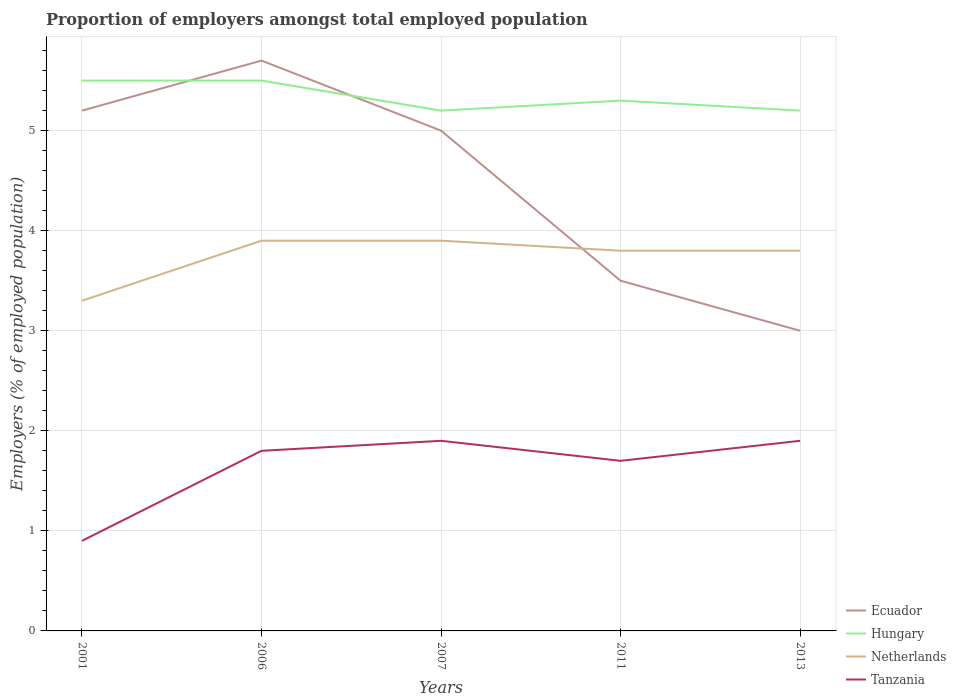Is the number of lines equal to the number of legend labels?
Your answer should be very brief. Yes. Across all years, what is the maximum proportion of employers in Netherlands?
Provide a short and direct response. 3.3. In which year was the proportion of employers in Hungary maximum?
Your response must be concise. 2007. What is the difference between the highest and the second highest proportion of employers in Hungary?
Offer a terse response. 0.3. How many lines are there?
Provide a succinct answer. 4. How many years are there in the graph?
Give a very brief answer. 5. Does the graph contain any zero values?
Give a very brief answer. No. Does the graph contain grids?
Your answer should be compact. Yes. Where does the legend appear in the graph?
Your answer should be very brief. Bottom right. How are the legend labels stacked?
Offer a very short reply. Vertical. What is the title of the graph?
Your answer should be very brief. Proportion of employers amongst total employed population. What is the label or title of the X-axis?
Keep it short and to the point. Years. What is the label or title of the Y-axis?
Provide a succinct answer. Employers (% of employed population). What is the Employers (% of employed population) of Ecuador in 2001?
Make the answer very short. 5.2. What is the Employers (% of employed population) in Hungary in 2001?
Your response must be concise. 5.5. What is the Employers (% of employed population) of Netherlands in 2001?
Your answer should be very brief. 3.3. What is the Employers (% of employed population) of Tanzania in 2001?
Offer a terse response. 0.9. What is the Employers (% of employed population) of Ecuador in 2006?
Give a very brief answer. 5.7. What is the Employers (% of employed population) in Netherlands in 2006?
Your answer should be very brief. 3.9. What is the Employers (% of employed population) of Tanzania in 2006?
Ensure brevity in your answer.  1.8. What is the Employers (% of employed population) in Hungary in 2007?
Make the answer very short. 5.2. What is the Employers (% of employed population) in Netherlands in 2007?
Provide a succinct answer. 3.9. What is the Employers (% of employed population) of Tanzania in 2007?
Ensure brevity in your answer.  1.9. What is the Employers (% of employed population) in Hungary in 2011?
Keep it short and to the point. 5.3. What is the Employers (% of employed population) of Netherlands in 2011?
Your answer should be compact. 3.8. What is the Employers (% of employed population) of Tanzania in 2011?
Give a very brief answer. 1.7. What is the Employers (% of employed population) of Ecuador in 2013?
Your answer should be very brief. 3. What is the Employers (% of employed population) in Hungary in 2013?
Provide a succinct answer. 5.2. What is the Employers (% of employed population) in Netherlands in 2013?
Your response must be concise. 3.8. What is the Employers (% of employed population) in Tanzania in 2013?
Your response must be concise. 1.9. Across all years, what is the maximum Employers (% of employed population) in Ecuador?
Offer a terse response. 5.7. Across all years, what is the maximum Employers (% of employed population) of Netherlands?
Provide a succinct answer. 3.9. Across all years, what is the maximum Employers (% of employed population) of Tanzania?
Your answer should be compact. 1.9. Across all years, what is the minimum Employers (% of employed population) of Hungary?
Your answer should be very brief. 5.2. Across all years, what is the minimum Employers (% of employed population) of Netherlands?
Give a very brief answer. 3.3. Across all years, what is the minimum Employers (% of employed population) of Tanzania?
Make the answer very short. 0.9. What is the total Employers (% of employed population) of Ecuador in the graph?
Your answer should be very brief. 22.4. What is the total Employers (% of employed population) in Hungary in the graph?
Offer a very short reply. 26.7. What is the total Employers (% of employed population) of Netherlands in the graph?
Give a very brief answer. 18.7. What is the total Employers (% of employed population) of Tanzania in the graph?
Provide a succinct answer. 8.2. What is the difference between the Employers (% of employed population) of Ecuador in 2001 and that in 2006?
Provide a succinct answer. -0.5. What is the difference between the Employers (% of employed population) of Ecuador in 2001 and that in 2011?
Provide a succinct answer. 1.7. What is the difference between the Employers (% of employed population) of Netherlands in 2001 and that in 2011?
Your answer should be compact. -0.5. What is the difference between the Employers (% of employed population) of Tanzania in 2001 and that in 2011?
Your response must be concise. -0.8. What is the difference between the Employers (% of employed population) in Hungary in 2001 and that in 2013?
Offer a terse response. 0.3. What is the difference between the Employers (% of employed population) of Tanzania in 2001 and that in 2013?
Make the answer very short. -1. What is the difference between the Employers (% of employed population) of Ecuador in 2006 and that in 2007?
Your answer should be compact. 0.7. What is the difference between the Employers (% of employed population) of Tanzania in 2006 and that in 2007?
Provide a succinct answer. -0.1. What is the difference between the Employers (% of employed population) of Ecuador in 2006 and that in 2011?
Provide a succinct answer. 2.2. What is the difference between the Employers (% of employed population) of Netherlands in 2006 and that in 2011?
Ensure brevity in your answer.  0.1. What is the difference between the Employers (% of employed population) of Tanzania in 2006 and that in 2011?
Offer a very short reply. 0.1. What is the difference between the Employers (% of employed population) in Netherlands in 2006 and that in 2013?
Provide a short and direct response. 0.1. What is the difference between the Employers (% of employed population) of Tanzania in 2007 and that in 2011?
Provide a short and direct response. 0.2. What is the difference between the Employers (% of employed population) in Ecuador in 2007 and that in 2013?
Offer a terse response. 2. What is the difference between the Employers (% of employed population) of Netherlands in 2007 and that in 2013?
Make the answer very short. 0.1. What is the difference between the Employers (% of employed population) of Tanzania in 2007 and that in 2013?
Offer a terse response. 0. What is the difference between the Employers (% of employed population) in Hungary in 2011 and that in 2013?
Keep it short and to the point. 0.1. What is the difference between the Employers (% of employed population) of Ecuador in 2001 and the Employers (% of employed population) of Netherlands in 2006?
Provide a succinct answer. 1.3. What is the difference between the Employers (% of employed population) in Ecuador in 2001 and the Employers (% of employed population) in Tanzania in 2006?
Ensure brevity in your answer.  3.4. What is the difference between the Employers (% of employed population) of Ecuador in 2001 and the Employers (% of employed population) of Netherlands in 2007?
Ensure brevity in your answer.  1.3. What is the difference between the Employers (% of employed population) of Hungary in 2001 and the Employers (% of employed population) of Tanzania in 2007?
Ensure brevity in your answer.  3.6. What is the difference between the Employers (% of employed population) of Netherlands in 2001 and the Employers (% of employed population) of Tanzania in 2007?
Offer a very short reply. 1.4. What is the difference between the Employers (% of employed population) of Ecuador in 2001 and the Employers (% of employed population) of Hungary in 2011?
Provide a short and direct response. -0.1. What is the difference between the Employers (% of employed population) in Hungary in 2001 and the Employers (% of employed population) in Netherlands in 2011?
Keep it short and to the point. 1.7. What is the difference between the Employers (% of employed population) of Ecuador in 2001 and the Employers (% of employed population) of Tanzania in 2013?
Offer a very short reply. 3.3. What is the difference between the Employers (% of employed population) in Hungary in 2001 and the Employers (% of employed population) in Tanzania in 2013?
Ensure brevity in your answer.  3.6. What is the difference between the Employers (% of employed population) in Netherlands in 2001 and the Employers (% of employed population) in Tanzania in 2013?
Your answer should be compact. 1.4. What is the difference between the Employers (% of employed population) of Ecuador in 2006 and the Employers (% of employed population) of Tanzania in 2007?
Offer a very short reply. 3.8. What is the difference between the Employers (% of employed population) in Netherlands in 2006 and the Employers (% of employed population) in Tanzania in 2007?
Give a very brief answer. 2. What is the difference between the Employers (% of employed population) of Ecuador in 2006 and the Employers (% of employed population) of Hungary in 2011?
Make the answer very short. 0.4. What is the difference between the Employers (% of employed population) in Ecuador in 2006 and the Employers (% of employed population) in Netherlands in 2011?
Offer a terse response. 1.9. What is the difference between the Employers (% of employed population) of Hungary in 2006 and the Employers (% of employed population) of Netherlands in 2011?
Your response must be concise. 1.7. What is the difference between the Employers (% of employed population) in Netherlands in 2006 and the Employers (% of employed population) in Tanzania in 2011?
Make the answer very short. 2.2. What is the difference between the Employers (% of employed population) of Ecuador in 2006 and the Employers (% of employed population) of Netherlands in 2013?
Your answer should be compact. 1.9. What is the difference between the Employers (% of employed population) in Ecuador in 2006 and the Employers (% of employed population) in Tanzania in 2013?
Your response must be concise. 3.8. What is the difference between the Employers (% of employed population) of Hungary in 2006 and the Employers (% of employed population) of Netherlands in 2013?
Offer a very short reply. 1.7. What is the difference between the Employers (% of employed population) in Netherlands in 2006 and the Employers (% of employed population) in Tanzania in 2013?
Keep it short and to the point. 2. What is the difference between the Employers (% of employed population) of Ecuador in 2007 and the Employers (% of employed population) of Hungary in 2011?
Provide a succinct answer. -0.3. What is the difference between the Employers (% of employed population) in Ecuador in 2007 and the Employers (% of employed population) in Netherlands in 2011?
Your response must be concise. 1.2. What is the difference between the Employers (% of employed population) of Hungary in 2007 and the Employers (% of employed population) of Netherlands in 2011?
Offer a very short reply. 1.4. What is the difference between the Employers (% of employed population) of Hungary in 2007 and the Employers (% of employed population) of Tanzania in 2011?
Give a very brief answer. 3.5. What is the difference between the Employers (% of employed population) of Netherlands in 2007 and the Employers (% of employed population) of Tanzania in 2011?
Your response must be concise. 2.2. What is the difference between the Employers (% of employed population) in Ecuador in 2007 and the Employers (% of employed population) in Netherlands in 2013?
Provide a succinct answer. 1.2. What is the difference between the Employers (% of employed population) in Ecuador in 2007 and the Employers (% of employed population) in Tanzania in 2013?
Your response must be concise. 3.1. What is the difference between the Employers (% of employed population) in Hungary in 2007 and the Employers (% of employed population) in Netherlands in 2013?
Your answer should be compact. 1.4. What is the difference between the Employers (% of employed population) in Hungary in 2007 and the Employers (% of employed population) in Tanzania in 2013?
Keep it short and to the point. 3.3. What is the average Employers (% of employed population) of Ecuador per year?
Your answer should be compact. 4.48. What is the average Employers (% of employed population) of Hungary per year?
Provide a succinct answer. 5.34. What is the average Employers (% of employed population) of Netherlands per year?
Make the answer very short. 3.74. What is the average Employers (% of employed population) in Tanzania per year?
Offer a terse response. 1.64. In the year 2001, what is the difference between the Employers (% of employed population) in Ecuador and Employers (% of employed population) in Hungary?
Your response must be concise. -0.3. In the year 2001, what is the difference between the Employers (% of employed population) of Hungary and Employers (% of employed population) of Tanzania?
Provide a succinct answer. 4.6. In the year 2001, what is the difference between the Employers (% of employed population) in Netherlands and Employers (% of employed population) in Tanzania?
Offer a very short reply. 2.4. In the year 2006, what is the difference between the Employers (% of employed population) in Ecuador and Employers (% of employed population) in Netherlands?
Ensure brevity in your answer.  1.8. In the year 2006, what is the difference between the Employers (% of employed population) of Ecuador and Employers (% of employed population) of Tanzania?
Provide a short and direct response. 3.9. In the year 2006, what is the difference between the Employers (% of employed population) of Hungary and Employers (% of employed population) of Netherlands?
Your response must be concise. 1.6. In the year 2006, what is the difference between the Employers (% of employed population) of Hungary and Employers (% of employed population) of Tanzania?
Make the answer very short. 3.7. In the year 2006, what is the difference between the Employers (% of employed population) of Netherlands and Employers (% of employed population) of Tanzania?
Provide a succinct answer. 2.1. In the year 2007, what is the difference between the Employers (% of employed population) of Ecuador and Employers (% of employed population) of Hungary?
Provide a short and direct response. -0.2. In the year 2011, what is the difference between the Employers (% of employed population) of Ecuador and Employers (% of employed population) of Netherlands?
Offer a very short reply. -0.3. In the year 2011, what is the difference between the Employers (% of employed population) in Ecuador and Employers (% of employed population) in Tanzania?
Ensure brevity in your answer.  1.8. In the year 2013, what is the difference between the Employers (% of employed population) of Ecuador and Employers (% of employed population) of Hungary?
Make the answer very short. -2.2. In the year 2013, what is the difference between the Employers (% of employed population) of Ecuador and Employers (% of employed population) of Tanzania?
Your answer should be very brief. 1.1. In the year 2013, what is the difference between the Employers (% of employed population) in Hungary and Employers (% of employed population) in Netherlands?
Give a very brief answer. 1.4. In the year 2013, what is the difference between the Employers (% of employed population) in Netherlands and Employers (% of employed population) in Tanzania?
Give a very brief answer. 1.9. What is the ratio of the Employers (% of employed population) of Ecuador in 2001 to that in 2006?
Give a very brief answer. 0.91. What is the ratio of the Employers (% of employed population) in Hungary in 2001 to that in 2006?
Ensure brevity in your answer.  1. What is the ratio of the Employers (% of employed population) of Netherlands in 2001 to that in 2006?
Give a very brief answer. 0.85. What is the ratio of the Employers (% of employed population) in Ecuador in 2001 to that in 2007?
Your answer should be very brief. 1.04. What is the ratio of the Employers (% of employed population) of Hungary in 2001 to that in 2007?
Your response must be concise. 1.06. What is the ratio of the Employers (% of employed population) of Netherlands in 2001 to that in 2007?
Provide a short and direct response. 0.85. What is the ratio of the Employers (% of employed population) of Tanzania in 2001 to that in 2007?
Provide a short and direct response. 0.47. What is the ratio of the Employers (% of employed population) of Ecuador in 2001 to that in 2011?
Your answer should be very brief. 1.49. What is the ratio of the Employers (% of employed population) in Hungary in 2001 to that in 2011?
Your answer should be very brief. 1.04. What is the ratio of the Employers (% of employed population) of Netherlands in 2001 to that in 2011?
Your answer should be very brief. 0.87. What is the ratio of the Employers (% of employed population) of Tanzania in 2001 to that in 2011?
Ensure brevity in your answer.  0.53. What is the ratio of the Employers (% of employed population) of Ecuador in 2001 to that in 2013?
Provide a short and direct response. 1.73. What is the ratio of the Employers (% of employed population) in Hungary in 2001 to that in 2013?
Your response must be concise. 1.06. What is the ratio of the Employers (% of employed population) in Netherlands in 2001 to that in 2013?
Give a very brief answer. 0.87. What is the ratio of the Employers (% of employed population) of Tanzania in 2001 to that in 2013?
Ensure brevity in your answer.  0.47. What is the ratio of the Employers (% of employed population) in Ecuador in 2006 to that in 2007?
Keep it short and to the point. 1.14. What is the ratio of the Employers (% of employed population) in Hungary in 2006 to that in 2007?
Provide a short and direct response. 1.06. What is the ratio of the Employers (% of employed population) in Netherlands in 2006 to that in 2007?
Your answer should be very brief. 1. What is the ratio of the Employers (% of employed population) in Tanzania in 2006 to that in 2007?
Offer a very short reply. 0.95. What is the ratio of the Employers (% of employed population) in Ecuador in 2006 to that in 2011?
Your answer should be compact. 1.63. What is the ratio of the Employers (% of employed population) in Hungary in 2006 to that in 2011?
Offer a terse response. 1.04. What is the ratio of the Employers (% of employed population) of Netherlands in 2006 to that in 2011?
Keep it short and to the point. 1.03. What is the ratio of the Employers (% of employed population) of Tanzania in 2006 to that in 2011?
Your answer should be compact. 1.06. What is the ratio of the Employers (% of employed population) in Ecuador in 2006 to that in 2013?
Make the answer very short. 1.9. What is the ratio of the Employers (% of employed population) of Hungary in 2006 to that in 2013?
Give a very brief answer. 1.06. What is the ratio of the Employers (% of employed population) in Netherlands in 2006 to that in 2013?
Give a very brief answer. 1.03. What is the ratio of the Employers (% of employed population) in Ecuador in 2007 to that in 2011?
Your answer should be compact. 1.43. What is the ratio of the Employers (% of employed population) in Hungary in 2007 to that in 2011?
Provide a short and direct response. 0.98. What is the ratio of the Employers (% of employed population) in Netherlands in 2007 to that in 2011?
Offer a very short reply. 1.03. What is the ratio of the Employers (% of employed population) in Tanzania in 2007 to that in 2011?
Provide a short and direct response. 1.12. What is the ratio of the Employers (% of employed population) of Ecuador in 2007 to that in 2013?
Your answer should be compact. 1.67. What is the ratio of the Employers (% of employed population) of Hungary in 2007 to that in 2013?
Your response must be concise. 1. What is the ratio of the Employers (% of employed population) of Netherlands in 2007 to that in 2013?
Offer a very short reply. 1.03. What is the ratio of the Employers (% of employed population) of Hungary in 2011 to that in 2013?
Make the answer very short. 1.02. What is the ratio of the Employers (% of employed population) in Tanzania in 2011 to that in 2013?
Your answer should be compact. 0.89. What is the difference between the highest and the second highest Employers (% of employed population) in Hungary?
Give a very brief answer. 0. What is the difference between the highest and the lowest Employers (% of employed population) in Hungary?
Keep it short and to the point. 0.3. What is the difference between the highest and the lowest Employers (% of employed population) in Netherlands?
Offer a terse response. 0.6. 